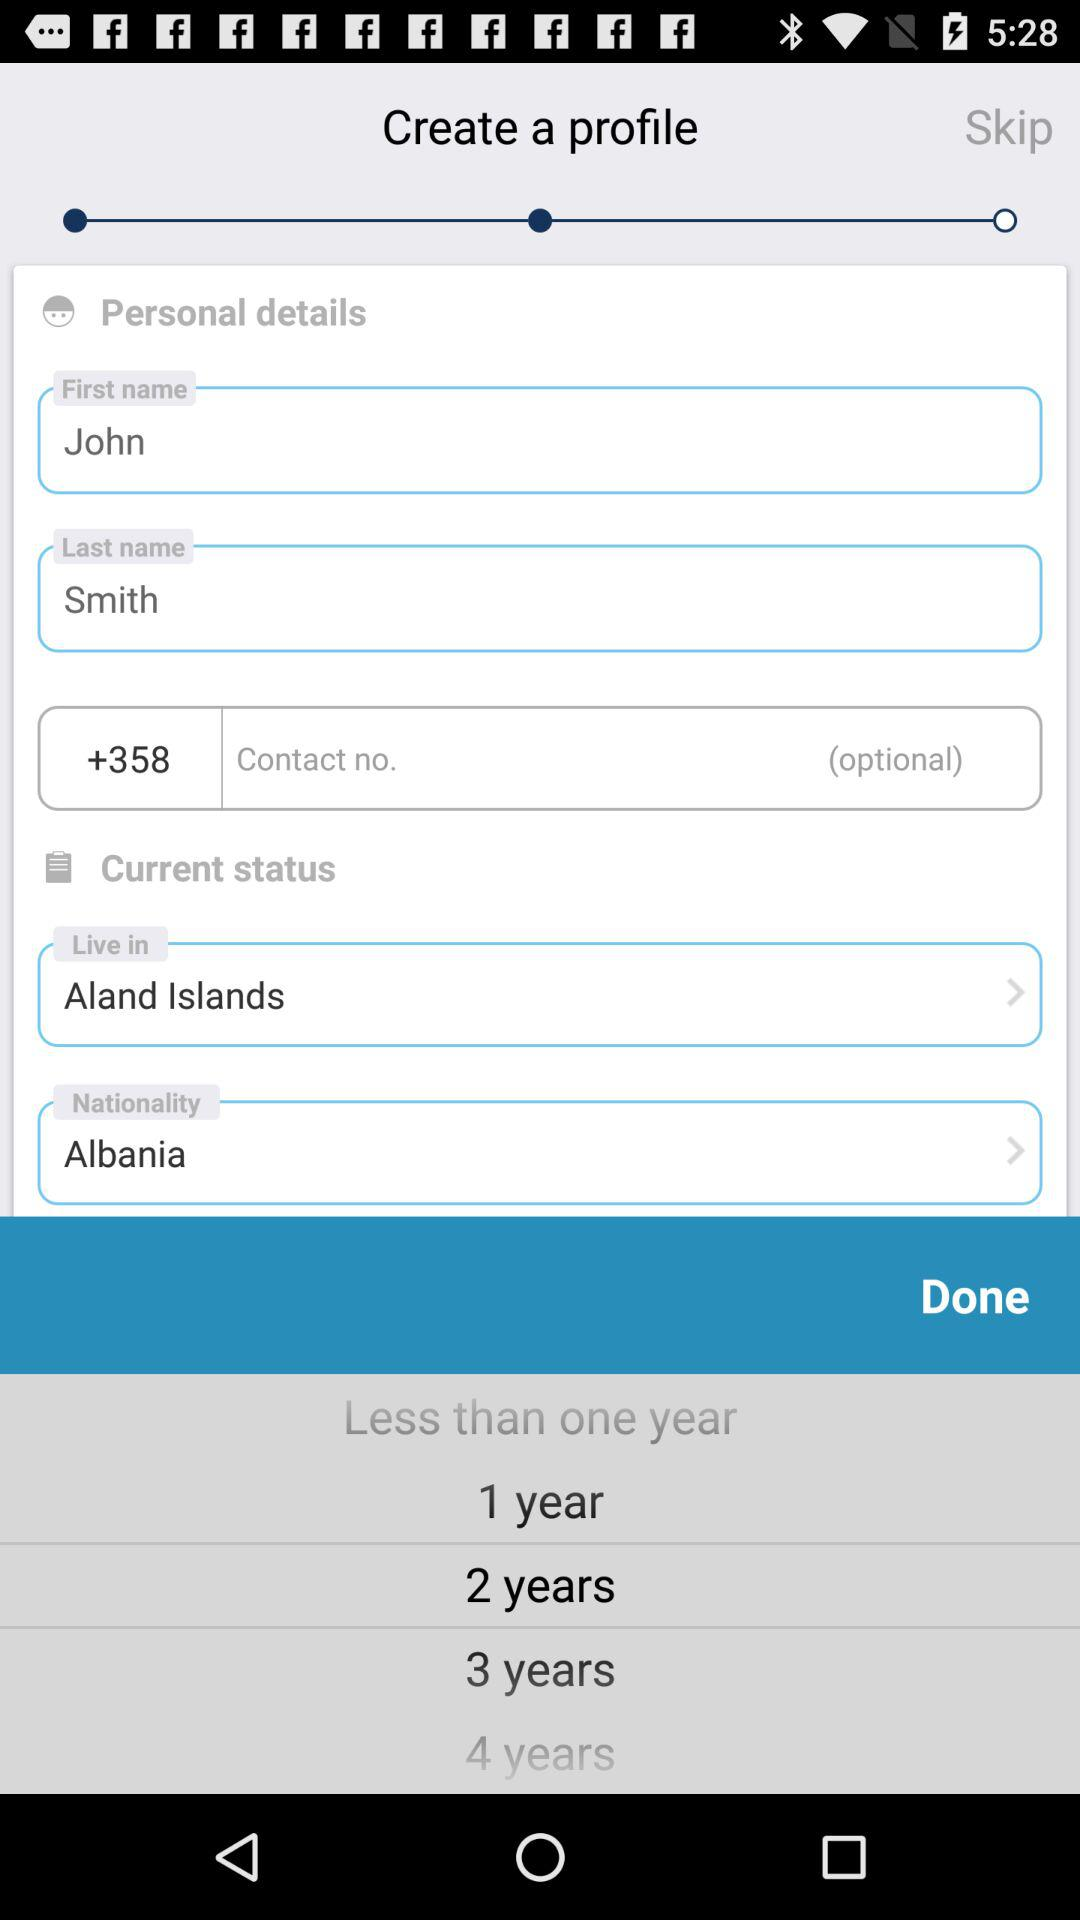Which is the nationality? The nationality is "Albania". 